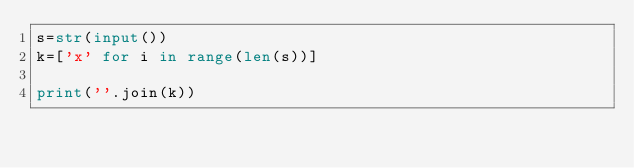<code> <loc_0><loc_0><loc_500><loc_500><_Python_>s=str(input())
k=['x' for i in range(len(s))]

print(''.join(k))</code> 